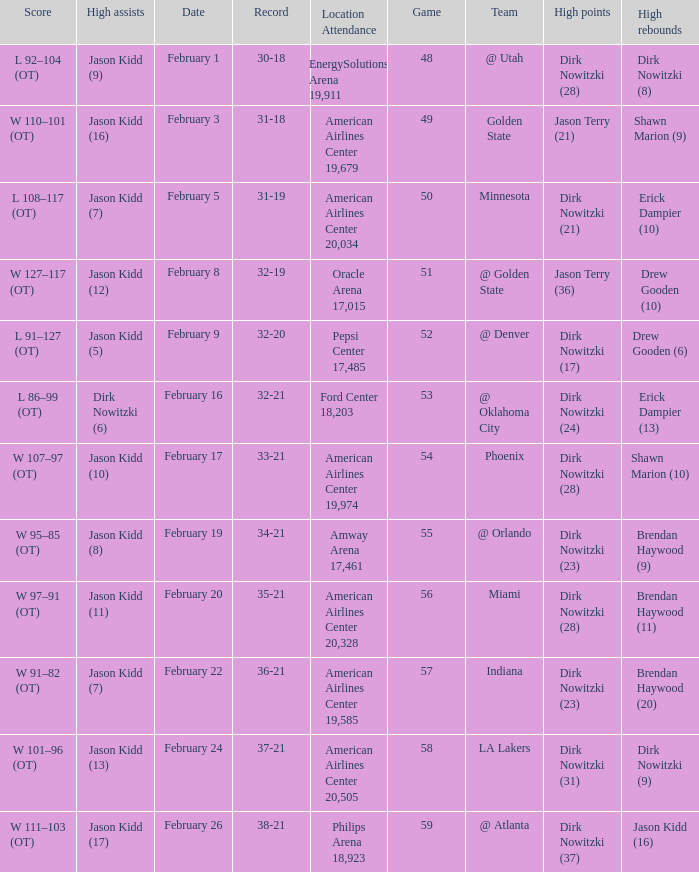Who had the most high assists with a record of 32-19? Jason Kidd (12). 